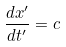<formula> <loc_0><loc_0><loc_500><loc_500>\frac { d x ^ { \prime } } { d t ^ { \prime } } = c</formula> 